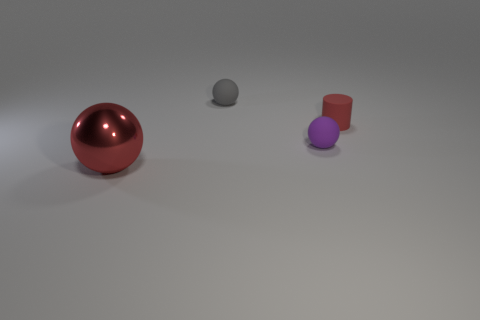Can you infer the approximate sizes of the objects relative to each other? Certainly. The large red sphere is the biggest object, with the small purple cylinder being slightly smaller. The tiny gray sphere is the smallest object, only a fraction of the size compared to others. 